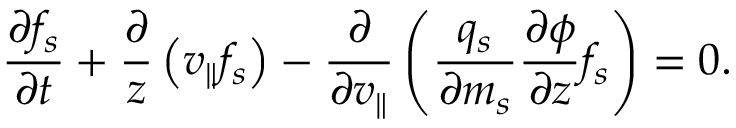Convert formula to latex. <formula><loc_0><loc_0><loc_500><loc_500>\frac { \partial f _ { s } } { \partial t } + \frac { \partial } { z } \left ( v _ { \| } f _ { s } \right ) - \frac { \partial } { \partial v _ { \| } } \left ( \frac { q _ { s } } { \partial m _ { s } } \frac { \partial \phi } { \partial z } f _ { s } \right ) = 0 .</formula> 